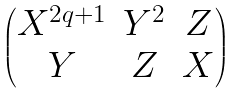<formula> <loc_0><loc_0><loc_500><loc_500>\begin{pmatrix} X ^ { 2 q + 1 } & Y ^ { 2 } & Z \\ Y & Z & X \end{pmatrix}</formula> 